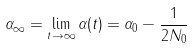Convert formula to latex. <formula><loc_0><loc_0><loc_500><loc_500>\alpha _ { \infty } = \lim _ { t \to \infty } \alpha ( t ) = \alpha _ { 0 } - \frac { 1 } { 2 N _ { 0 } }</formula> 